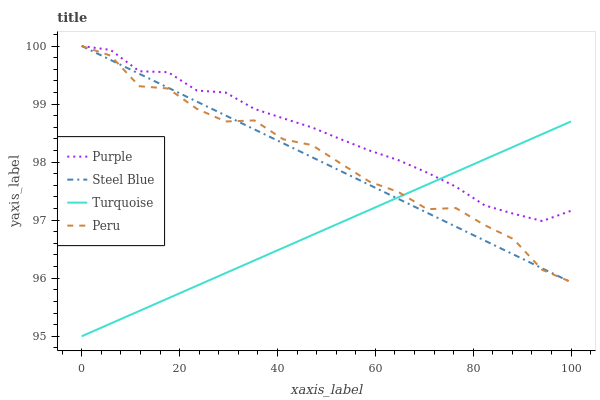Does Turquoise have the minimum area under the curve?
Answer yes or no. Yes. Does Purple have the maximum area under the curve?
Answer yes or no. Yes. Does Steel Blue have the minimum area under the curve?
Answer yes or no. No. Does Steel Blue have the maximum area under the curve?
Answer yes or no. No. Is Turquoise the smoothest?
Answer yes or no. Yes. Is Peru the roughest?
Answer yes or no. Yes. Is Steel Blue the smoothest?
Answer yes or no. No. Is Steel Blue the roughest?
Answer yes or no. No. Does Turquoise have the lowest value?
Answer yes or no. Yes. Does Steel Blue have the lowest value?
Answer yes or no. No. Does Peru have the highest value?
Answer yes or no. Yes. Does Turquoise have the highest value?
Answer yes or no. No. Does Steel Blue intersect Purple?
Answer yes or no. Yes. Is Steel Blue less than Purple?
Answer yes or no. No. Is Steel Blue greater than Purple?
Answer yes or no. No. 